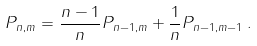Convert formula to latex. <formula><loc_0><loc_0><loc_500><loc_500>P _ { n , m } = \frac { n - 1 } { n } P _ { n - 1 , m } + \frac { 1 } { n } P _ { n - 1 , m - 1 } \, .</formula> 